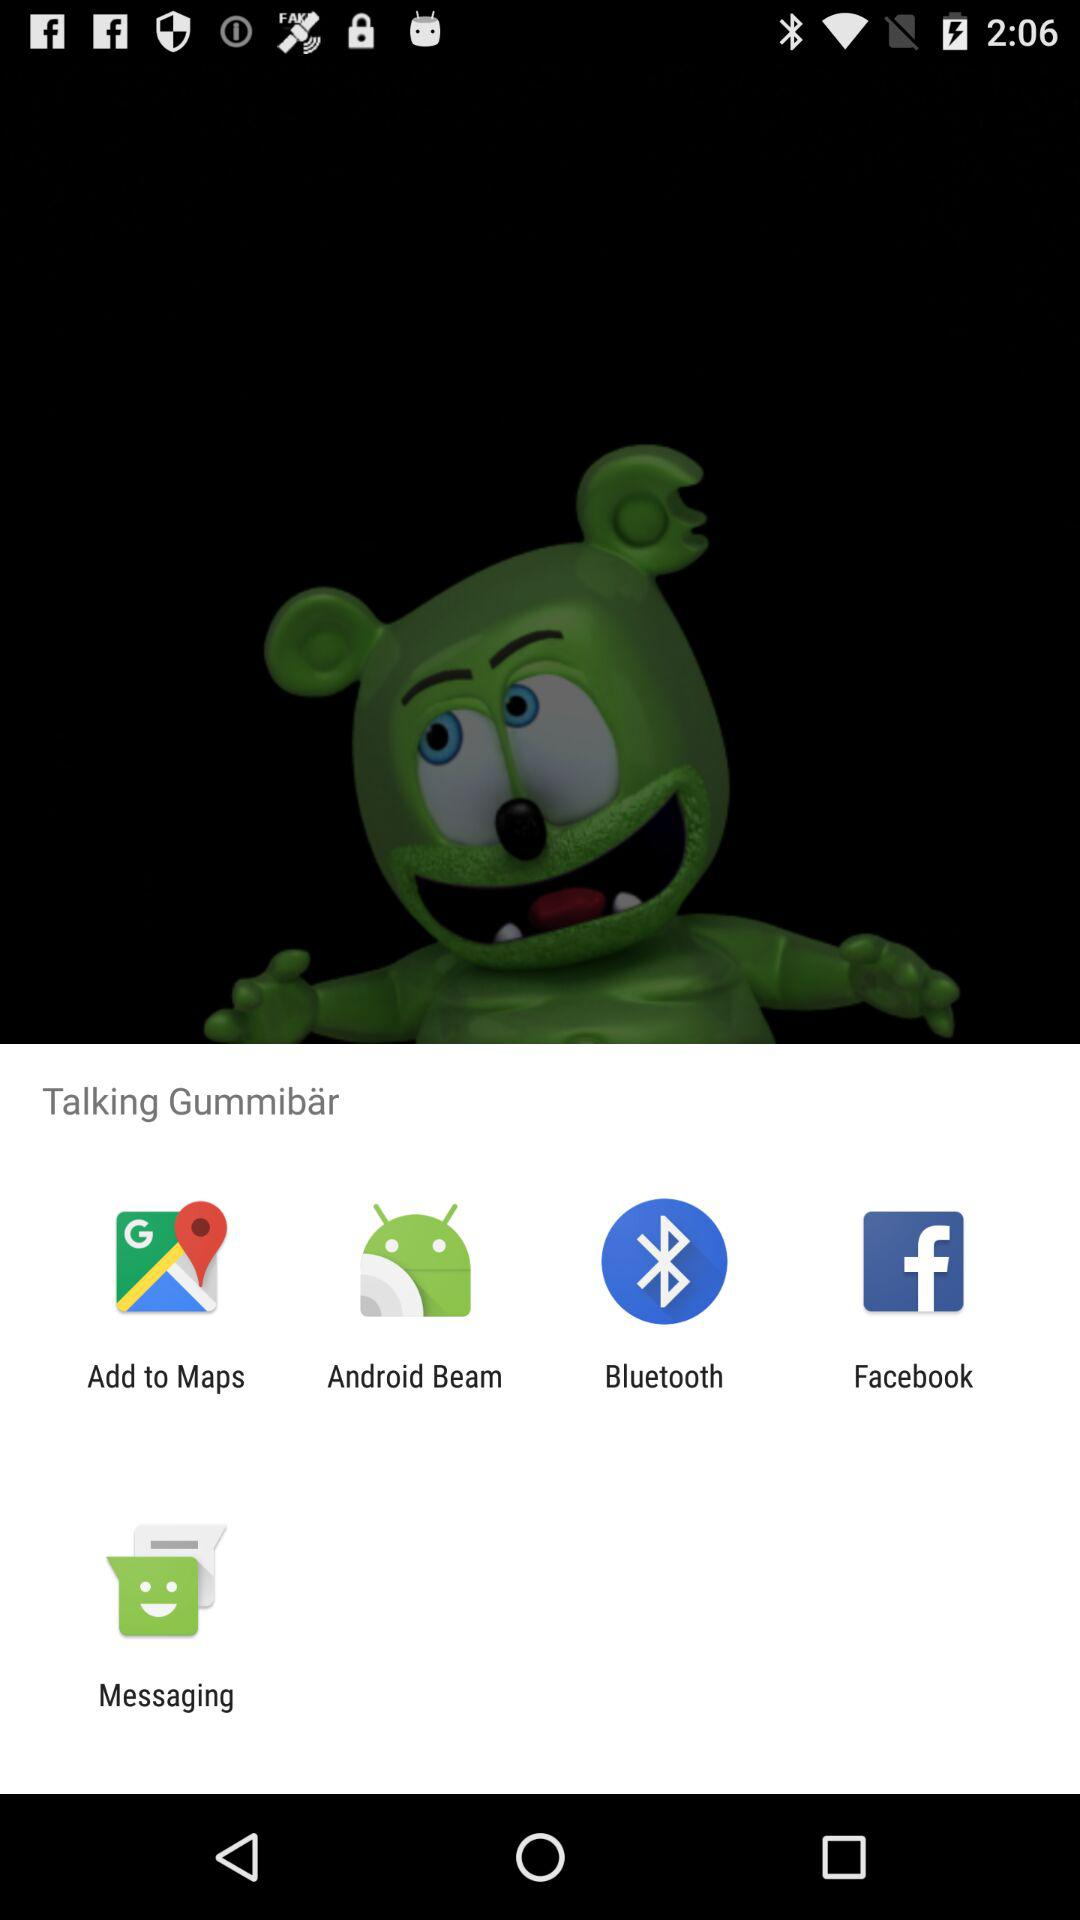Which application can I use to share? The applications that you can use to share are "Add to Maps", "Android Beam", "Bluetooth", "Facebook" and "Messaging". 